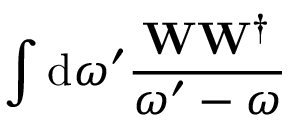<formula> <loc_0><loc_0><loc_500><loc_500>\int { d \omega ^ { \prime } \frac { W W ^ { \dagger } } { \omega ^ { \prime } - \omega } }</formula> 